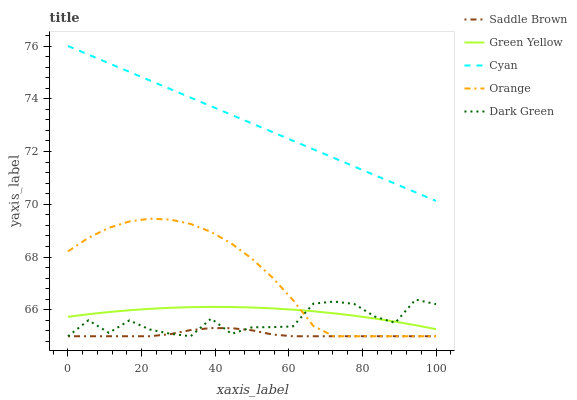Does Saddle Brown have the minimum area under the curve?
Answer yes or no. Yes. Does Cyan have the maximum area under the curve?
Answer yes or no. Yes. Does Green Yellow have the minimum area under the curve?
Answer yes or no. No. Does Green Yellow have the maximum area under the curve?
Answer yes or no. No. Is Cyan the smoothest?
Answer yes or no. Yes. Is Dark Green the roughest?
Answer yes or no. Yes. Is Green Yellow the smoothest?
Answer yes or no. No. Is Green Yellow the roughest?
Answer yes or no. No. Does Orange have the lowest value?
Answer yes or no. Yes. Does Green Yellow have the lowest value?
Answer yes or no. No. Does Cyan have the highest value?
Answer yes or no. Yes. Does Green Yellow have the highest value?
Answer yes or no. No. Is Saddle Brown less than Cyan?
Answer yes or no. Yes. Is Cyan greater than Orange?
Answer yes or no. Yes. Does Dark Green intersect Orange?
Answer yes or no. Yes. Is Dark Green less than Orange?
Answer yes or no. No. Is Dark Green greater than Orange?
Answer yes or no. No. Does Saddle Brown intersect Cyan?
Answer yes or no. No. 